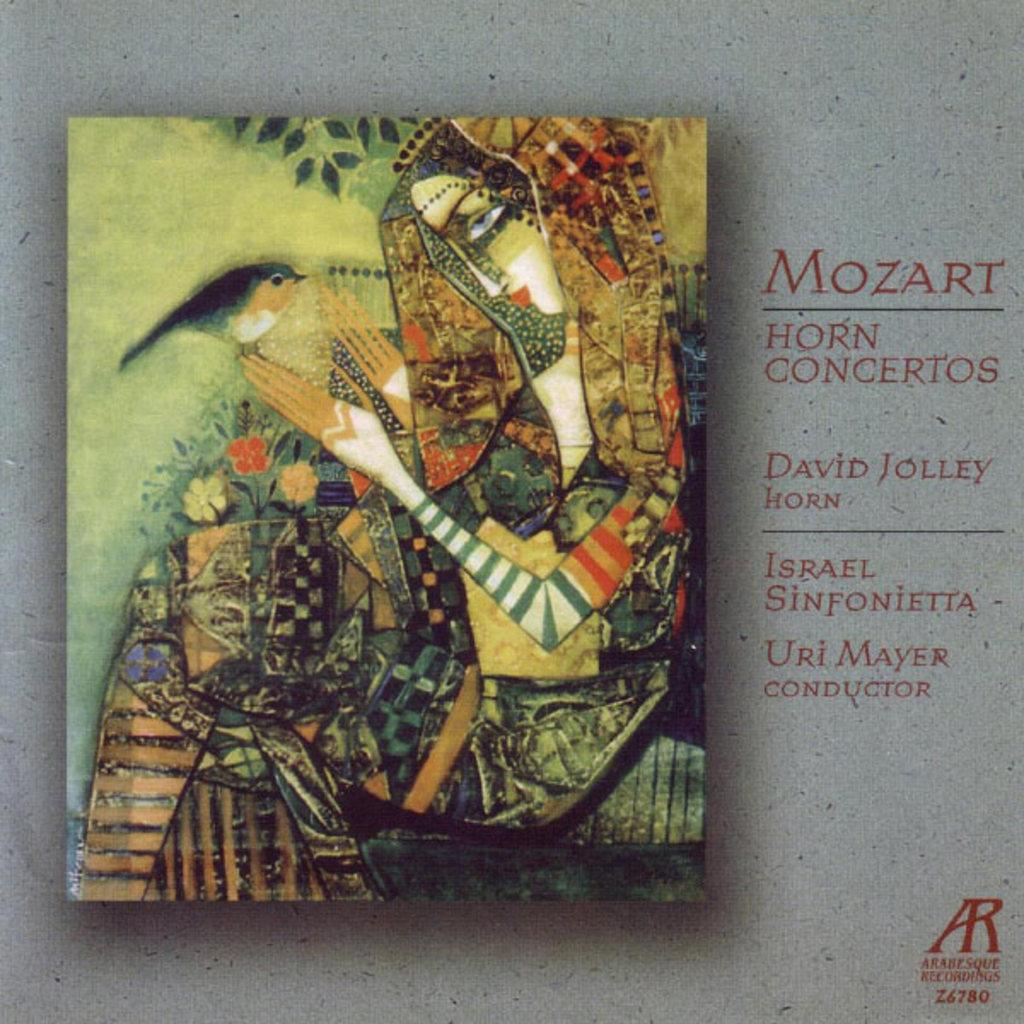What is the main subject of the painting in the image? The painting depicts a girl. What is the girl doing in the painting? The girl is holding a bird in the painting. How is the girl holding the bird? The girl is holding the bird with her fingers. What type of lock can be seen on the ground in the image? There is no lock present on the ground in the image. 